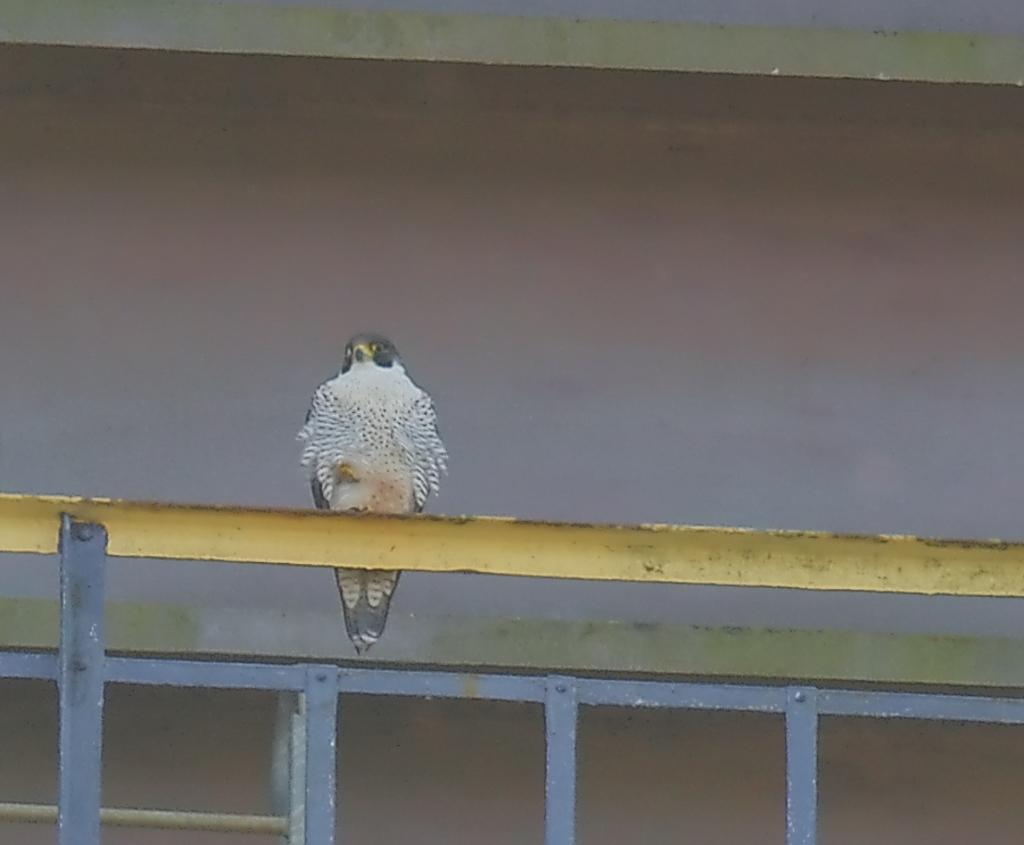What type of structure can be seen in the image? There is a wall in the image. Are there any openings in the wall? Yes, there are windows in the image. What can be seen outside the windows? Unfortunately, the image does not provide enough information to determine what can be seen outside the windows. Is there any wildlife visible in the image? Yes, there is a bird in the image. What color is the hammer hanging from the chain in the image? There is no hammer or chain present in the image. 